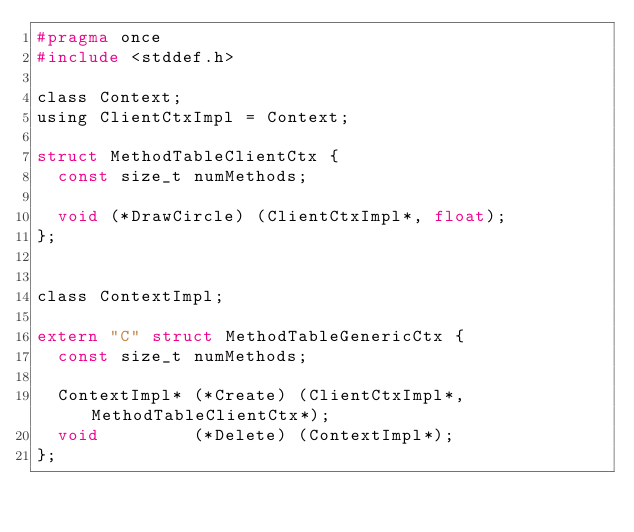Convert code to text. <code><loc_0><loc_0><loc_500><loc_500><_C_>#pragma once
#include <stddef.h>

class Context;
using ClientCtxImpl = Context;

struct MethodTableClientCtx {
  const size_t numMethods;

  void (*DrawCircle) (ClientCtxImpl*, float);
};


class ContextImpl;

extern "C" struct MethodTableGenericCtx {
  const size_t numMethods;

  ContextImpl* (*Create) (ClientCtxImpl*, MethodTableClientCtx*);
  void         (*Delete) (ContextImpl*);
};
</code> 